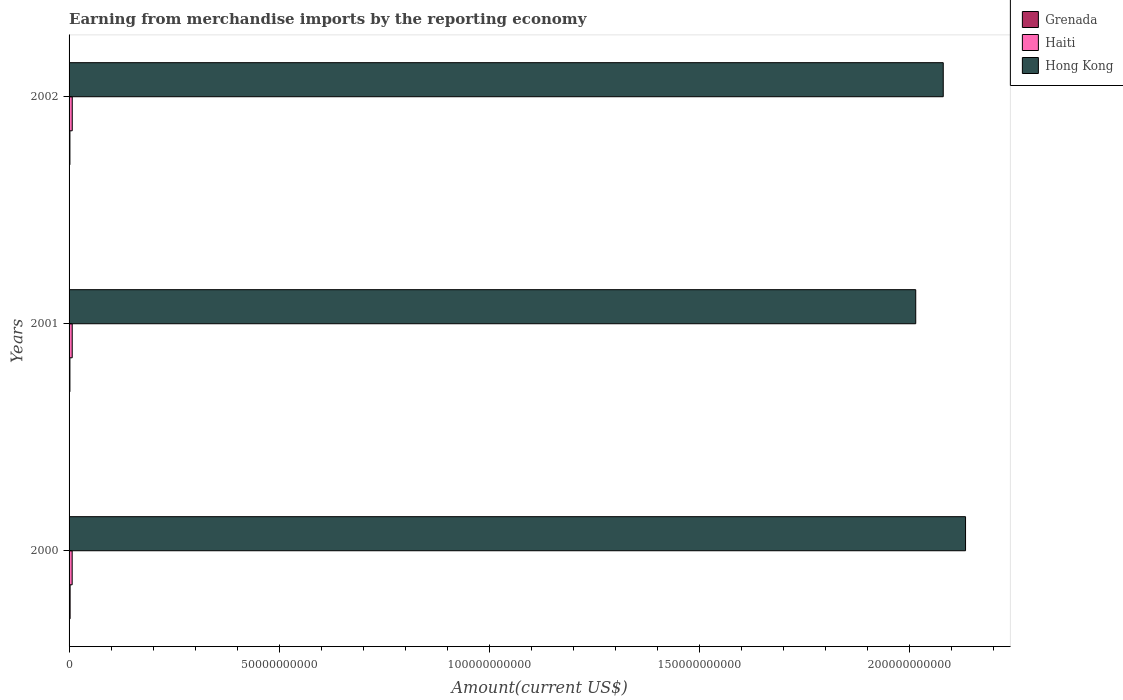How many different coloured bars are there?
Your answer should be very brief. 3. Are the number of bars per tick equal to the number of legend labels?
Your response must be concise. Yes. Are the number of bars on each tick of the Y-axis equal?
Your answer should be very brief. Yes. How many bars are there on the 2nd tick from the bottom?
Offer a terse response. 3. What is the label of the 3rd group of bars from the top?
Give a very brief answer. 2000. What is the amount earned from merchandise imports in Haiti in 2000?
Your answer should be very brief. 7.37e+08. Across all years, what is the maximum amount earned from merchandise imports in Hong Kong?
Your response must be concise. 2.13e+11. Across all years, what is the minimum amount earned from merchandise imports in Haiti?
Your response must be concise. 7.37e+08. In which year was the amount earned from merchandise imports in Haiti maximum?
Your response must be concise. 2002. What is the total amount earned from merchandise imports in Hong Kong in the graph?
Provide a short and direct response. 6.23e+11. What is the difference between the amount earned from merchandise imports in Hong Kong in 2000 and that in 2001?
Keep it short and to the point. 1.19e+1. What is the difference between the amount earned from merchandise imports in Grenada in 2000 and the amount earned from merchandise imports in Hong Kong in 2002?
Keep it short and to the point. -2.08e+11. What is the average amount earned from merchandise imports in Hong Kong per year?
Ensure brevity in your answer.  2.08e+11. In the year 2000, what is the difference between the amount earned from merchandise imports in Hong Kong and amount earned from merchandise imports in Grenada?
Your answer should be very brief. 2.13e+11. In how many years, is the amount earned from merchandise imports in Haiti greater than 50000000000 US$?
Provide a short and direct response. 0. What is the ratio of the amount earned from merchandise imports in Grenada in 2001 to that in 2002?
Your answer should be very brief. 1.01. Is the amount earned from merchandise imports in Hong Kong in 2001 less than that in 2002?
Give a very brief answer. Yes. What is the difference between the highest and the second highest amount earned from merchandise imports in Grenada?
Provide a succinct answer. 4.13e+07. What is the difference between the highest and the lowest amount earned from merchandise imports in Haiti?
Your response must be concise. 2.12e+07. In how many years, is the amount earned from merchandise imports in Haiti greater than the average amount earned from merchandise imports in Haiti taken over all years?
Your answer should be compact. 2. Is the sum of the amount earned from merchandise imports in Grenada in 2000 and 2001 greater than the maximum amount earned from merchandise imports in Haiti across all years?
Provide a short and direct response. No. What does the 2nd bar from the top in 2000 represents?
Your answer should be very brief. Haiti. What does the 1st bar from the bottom in 2001 represents?
Your answer should be very brief. Grenada. Is it the case that in every year, the sum of the amount earned from merchandise imports in Haiti and amount earned from merchandise imports in Hong Kong is greater than the amount earned from merchandise imports in Grenada?
Make the answer very short. Yes. How many bars are there?
Make the answer very short. 9. What is the difference between two consecutive major ticks on the X-axis?
Keep it short and to the point. 5.00e+1. Does the graph contain any zero values?
Give a very brief answer. No. What is the title of the graph?
Make the answer very short. Earning from merchandise imports by the reporting economy. What is the label or title of the X-axis?
Offer a very short reply. Amount(current US$). What is the Amount(current US$) in Grenada in 2000?
Offer a terse response. 2.46e+08. What is the Amount(current US$) in Haiti in 2000?
Your answer should be compact. 7.37e+08. What is the Amount(current US$) of Hong Kong in 2000?
Offer a very short reply. 2.13e+11. What is the Amount(current US$) of Grenada in 2001?
Give a very brief answer. 2.04e+08. What is the Amount(current US$) of Haiti in 2001?
Offer a very short reply. 7.49e+08. What is the Amount(current US$) of Hong Kong in 2001?
Keep it short and to the point. 2.01e+11. What is the Amount(current US$) in Grenada in 2002?
Give a very brief answer. 2.03e+08. What is the Amount(current US$) of Haiti in 2002?
Your answer should be very brief. 7.58e+08. What is the Amount(current US$) in Hong Kong in 2002?
Make the answer very short. 2.08e+11. Across all years, what is the maximum Amount(current US$) in Grenada?
Keep it short and to the point. 2.46e+08. Across all years, what is the maximum Amount(current US$) of Haiti?
Provide a succinct answer. 7.58e+08. Across all years, what is the maximum Amount(current US$) of Hong Kong?
Provide a short and direct response. 2.13e+11. Across all years, what is the minimum Amount(current US$) in Grenada?
Provide a succinct answer. 2.03e+08. Across all years, what is the minimum Amount(current US$) in Haiti?
Make the answer very short. 7.37e+08. Across all years, what is the minimum Amount(current US$) of Hong Kong?
Offer a terse response. 2.01e+11. What is the total Amount(current US$) of Grenada in the graph?
Make the answer very short. 6.53e+08. What is the total Amount(current US$) in Haiti in the graph?
Offer a terse response. 2.24e+09. What is the total Amount(current US$) of Hong Kong in the graph?
Offer a terse response. 6.23e+11. What is the difference between the Amount(current US$) in Grenada in 2000 and that in 2001?
Ensure brevity in your answer.  4.13e+07. What is the difference between the Amount(current US$) in Haiti in 2000 and that in 2001?
Your answer should be compact. -1.19e+07. What is the difference between the Amount(current US$) of Hong Kong in 2000 and that in 2001?
Keep it short and to the point. 1.19e+1. What is the difference between the Amount(current US$) of Grenada in 2000 and that in 2002?
Provide a succinct answer. 4.29e+07. What is the difference between the Amount(current US$) in Haiti in 2000 and that in 2002?
Give a very brief answer. -2.12e+07. What is the difference between the Amount(current US$) in Hong Kong in 2000 and that in 2002?
Provide a short and direct response. 5.30e+09. What is the difference between the Amount(current US$) in Grenada in 2001 and that in 2002?
Provide a short and direct response. 1.60e+06. What is the difference between the Amount(current US$) of Haiti in 2001 and that in 2002?
Keep it short and to the point. -9.28e+06. What is the difference between the Amount(current US$) in Hong Kong in 2001 and that in 2002?
Ensure brevity in your answer.  -6.55e+09. What is the difference between the Amount(current US$) of Grenada in 2000 and the Amount(current US$) of Haiti in 2001?
Your response must be concise. -5.03e+08. What is the difference between the Amount(current US$) of Grenada in 2000 and the Amount(current US$) of Hong Kong in 2001?
Give a very brief answer. -2.01e+11. What is the difference between the Amount(current US$) in Haiti in 2000 and the Amount(current US$) in Hong Kong in 2001?
Keep it short and to the point. -2.01e+11. What is the difference between the Amount(current US$) of Grenada in 2000 and the Amount(current US$) of Haiti in 2002?
Offer a terse response. -5.12e+08. What is the difference between the Amount(current US$) in Grenada in 2000 and the Amount(current US$) in Hong Kong in 2002?
Keep it short and to the point. -2.08e+11. What is the difference between the Amount(current US$) in Haiti in 2000 and the Amount(current US$) in Hong Kong in 2002?
Give a very brief answer. -2.07e+11. What is the difference between the Amount(current US$) in Grenada in 2001 and the Amount(current US$) in Haiti in 2002?
Give a very brief answer. -5.53e+08. What is the difference between the Amount(current US$) of Grenada in 2001 and the Amount(current US$) of Hong Kong in 2002?
Offer a terse response. -2.08e+11. What is the difference between the Amount(current US$) in Haiti in 2001 and the Amount(current US$) in Hong Kong in 2002?
Your answer should be compact. -2.07e+11. What is the average Amount(current US$) in Grenada per year?
Your answer should be very brief. 2.18e+08. What is the average Amount(current US$) in Haiti per year?
Offer a very short reply. 7.48e+08. What is the average Amount(current US$) of Hong Kong per year?
Provide a short and direct response. 2.08e+11. In the year 2000, what is the difference between the Amount(current US$) of Grenada and Amount(current US$) of Haiti?
Offer a very short reply. -4.91e+08. In the year 2000, what is the difference between the Amount(current US$) in Grenada and Amount(current US$) in Hong Kong?
Provide a succinct answer. -2.13e+11. In the year 2000, what is the difference between the Amount(current US$) of Haiti and Amount(current US$) of Hong Kong?
Give a very brief answer. -2.13e+11. In the year 2001, what is the difference between the Amount(current US$) in Grenada and Amount(current US$) in Haiti?
Give a very brief answer. -5.44e+08. In the year 2001, what is the difference between the Amount(current US$) of Grenada and Amount(current US$) of Hong Kong?
Keep it short and to the point. -2.01e+11. In the year 2001, what is the difference between the Amount(current US$) of Haiti and Amount(current US$) of Hong Kong?
Your answer should be very brief. -2.01e+11. In the year 2002, what is the difference between the Amount(current US$) of Grenada and Amount(current US$) of Haiti?
Your answer should be very brief. -5.55e+08. In the year 2002, what is the difference between the Amount(current US$) of Grenada and Amount(current US$) of Hong Kong?
Ensure brevity in your answer.  -2.08e+11. In the year 2002, what is the difference between the Amount(current US$) in Haiti and Amount(current US$) in Hong Kong?
Your answer should be very brief. -2.07e+11. What is the ratio of the Amount(current US$) in Grenada in 2000 to that in 2001?
Provide a short and direct response. 1.2. What is the ratio of the Amount(current US$) of Haiti in 2000 to that in 2001?
Your answer should be compact. 0.98. What is the ratio of the Amount(current US$) in Hong Kong in 2000 to that in 2001?
Your response must be concise. 1.06. What is the ratio of the Amount(current US$) in Grenada in 2000 to that in 2002?
Offer a terse response. 1.21. What is the ratio of the Amount(current US$) in Haiti in 2000 to that in 2002?
Provide a short and direct response. 0.97. What is the ratio of the Amount(current US$) of Hong Kong in 2000 to that in 2002?
Give a very brief answer. 1.03. What is the ratio of the Amount(current US$) of Grenada in 2001 to that in 2002?
Your response must be concise. 1.01. What is the ratio of the Amount(current US$) in Haiti in 2001 to that in 2002?
Your answer should be very brief. 0.99. What is the ratio of the Amount(current US$) in Hong Kong in 2001 to that in 2002?
Provide a succinct answer. 0.97. What is the difference between the highest and the second highest Amount(current US$) of Grenada?
Provide a succinct answer. 4.13e+07. What is the difference between the highest and the second highest Amount(current US$) of Haiti?
Offer a very short reply. 9.28e+06. What is the difference between the highest and the second highest Amount(current US$) of Hong Kong?
Provide a succinct answer. 5.30e+09. What is the difference between the highest and the lowest Amount(current US$) of Grenada?
Your response must be concise. 4.29e+07. What is the difference between the highest and the lowest Amount(current US$) of Haiti?
Offer a very short reply. 2.12e+07. What is the difference between the highest and the lowest Amount(current US$) in Hong Kong?
Your response must be concise. 1.19e+1. 